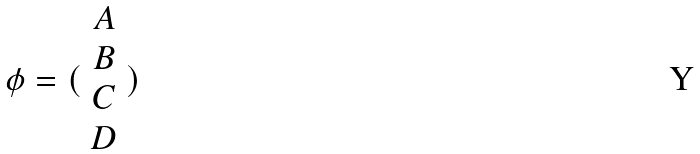<formula> <loc_0><loc_0><loc_500><loc_500>\phi = ( \begin{array} { c } A \\ B \\ C \\ D \end{array} )</formula> 